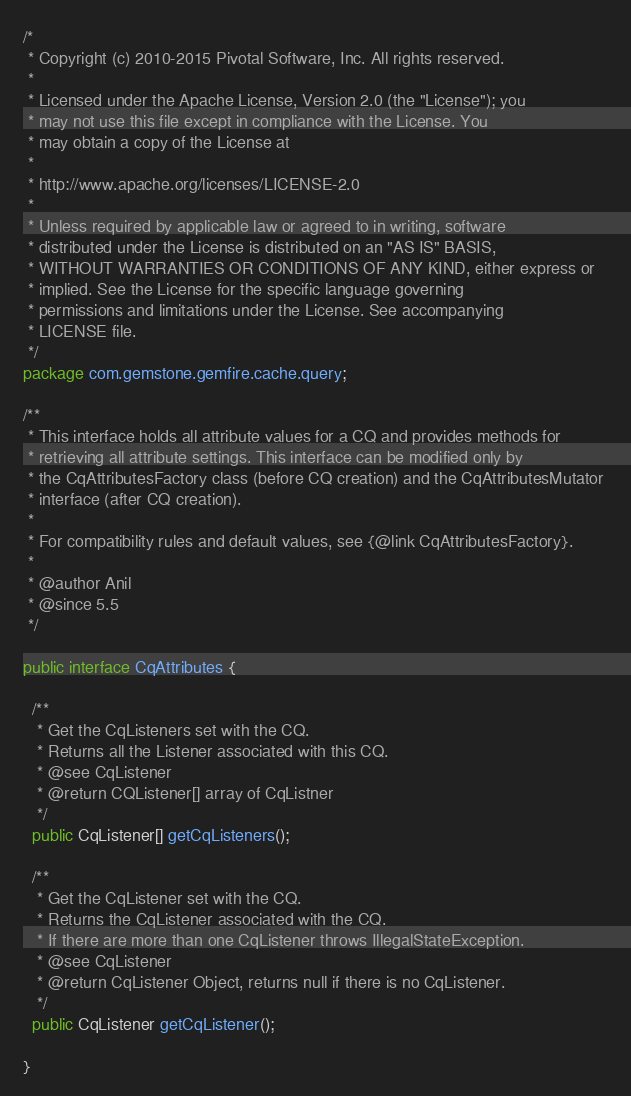<code> <loc_0><loc_0><loc_500><loc_500><_Java_>/*
 * Copyright (c) 2010-2015 Pivotal Software, Inc. All rights reserved.
 *
 * Licensed under the Apache License, Version 2.0 (the "License"); you
 * may not use this file except in compliance with the License. You
 * may obtain a copy of the License at
 *
 * http://www.apache.org/licenses/LICENSE-2.0
 *
 * Unless required by applicable law or agreed to in writing, software
 * distributed under the License is distributed on an "AS IS" BASIS,
 * WITHOUT WARRANTIES OR CONDITIONS OF ANY KIND, either express or
 * implied. See the License for the specific language governing
 * permissions and limitations under the License. See accompanying
 * LICENSE file.
 */
package com.gemstone.gemfire.cache.query;

/** 
 * This interface holds all attribute values for a CQ and provides methods for 
 * retrieving all attribute settings. This interface can be modified only by 
 * the CqAttributesFactory class (before CQ creation) and the CqAttributesMutator 
 * interface (after CQ creation).
 * 
 * For compatibility rules and default values, see {@link CqAttributesFactory}.
 *
 * @author Anil
 * @since 5.5
 */

public interface CqAttributes {
    
  /**
   * Get the CqListeners set with the CQ.
   * Returns all the Listener associated with this CQ.
   * @see CqListener
   * @return CQListener[] array of CqListner
   */
  public CqListener[] getCqListeners();
  
  /**
   * Get the CqListener set with the CQ.
   * Returns the CqListener associated with the CQ. 
   * If there are more than one CqListener throws IllegalStateException. 
   * @see CqListener
   * @return CqListener Object, returns null if there is no CqListener.      
   */
  public CqListener getCqListener();
   
}
</code> 